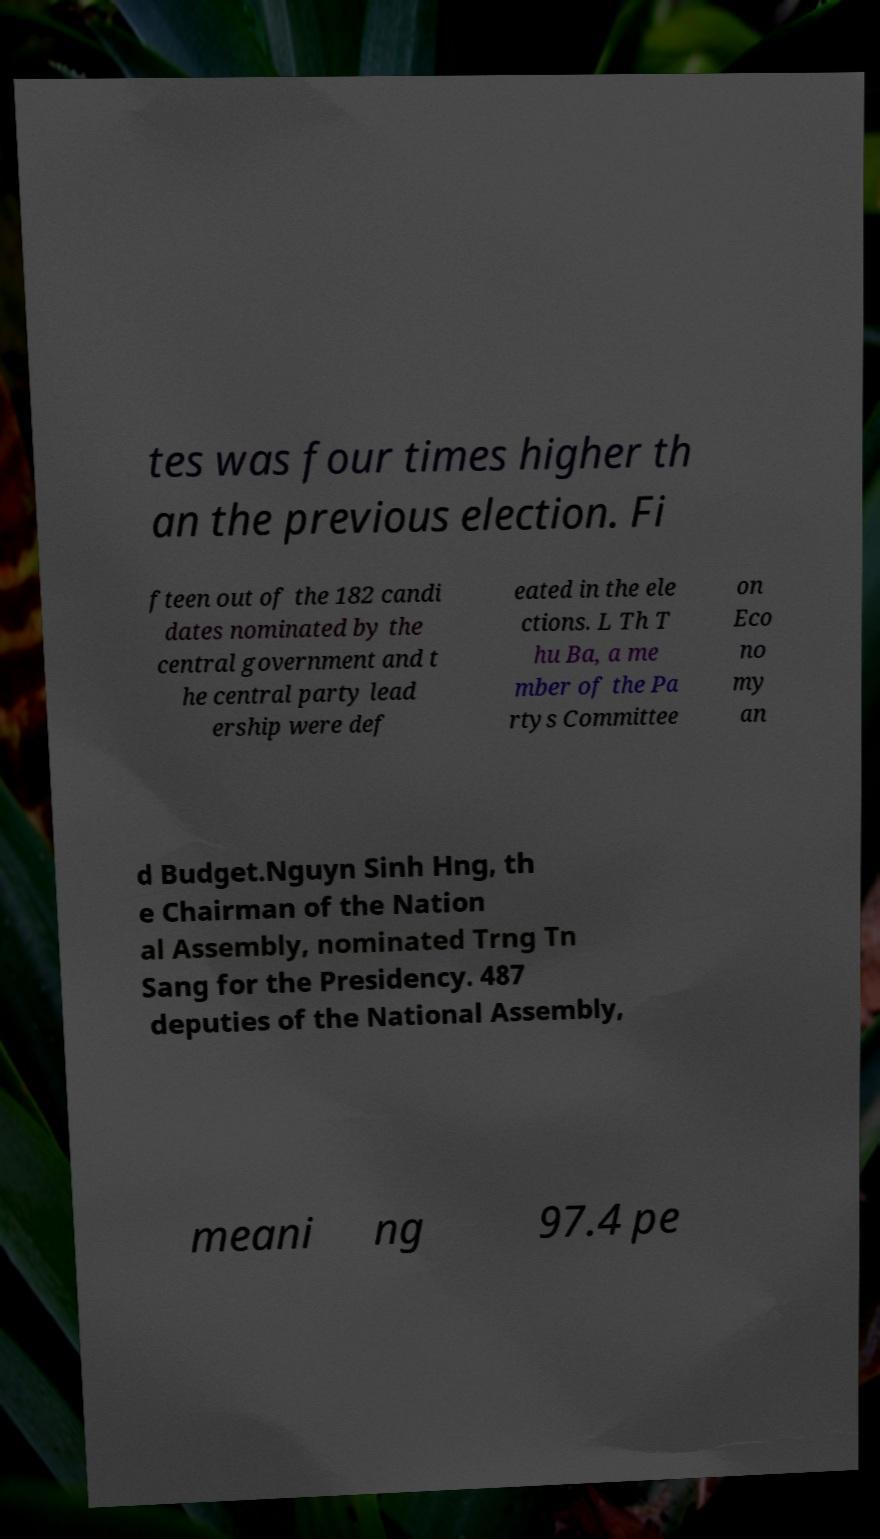Could you extract and type out the text from this image? tes was four times higher th an the previous election. Fi fteen out of the 182 candi dates nominated by the central government and t he central party lead ership were def eated in the ele ctions. L Th T hu Ba, a me mber of the Pa rtys Committee on Eco no my an d Budget.Nguyn Sinh Hng, th e Chairman of the Nation al Assembly, nominated Trng Tn Sang for the Presidency. 487 deputies of the National Assembly, meani ng 97.4 pe 